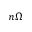<formula> <loc_0><loc_0><loc_500><loc_500>n \Omega</formula> 